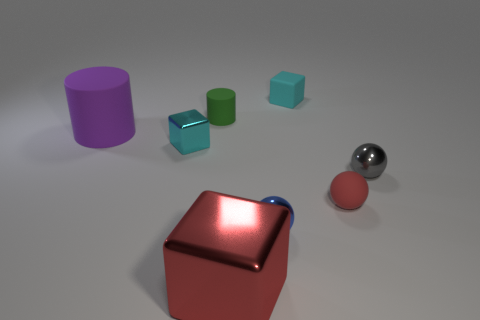How many other things are there of the same color as the rubber ball?
Your response must be concise. 1. There is a metallic object that is the same color as the tiny matte cube; what size is it?
Offer a very short reply. Small. The matte cube that is the same size as the gray metallic thing is what color?
Provide a succinct answer. Cyan. Is the material of the green thing the same as the small blue sphere?
Provide a short and direct response. No. How many metallic things have the same color as the tiny metallic cube?
Make the answer very short. 0. Is the color of the large cube the same as the small rubber ball?
Ensure brevity in your answer.  Yes. There is a red thing that is behind the big block; what is its material?
Give a very brief answer. Rubber. How many large objects are blue objects or gray spheres?
Offer a very short reply. 0. There is a large block that is the same color as the rubber ball; what material is it?
Your answer should be very brief. Metal. Is there a tiny yellow cube that has the same material as the gray ball?
Offer a very short reply. No. 